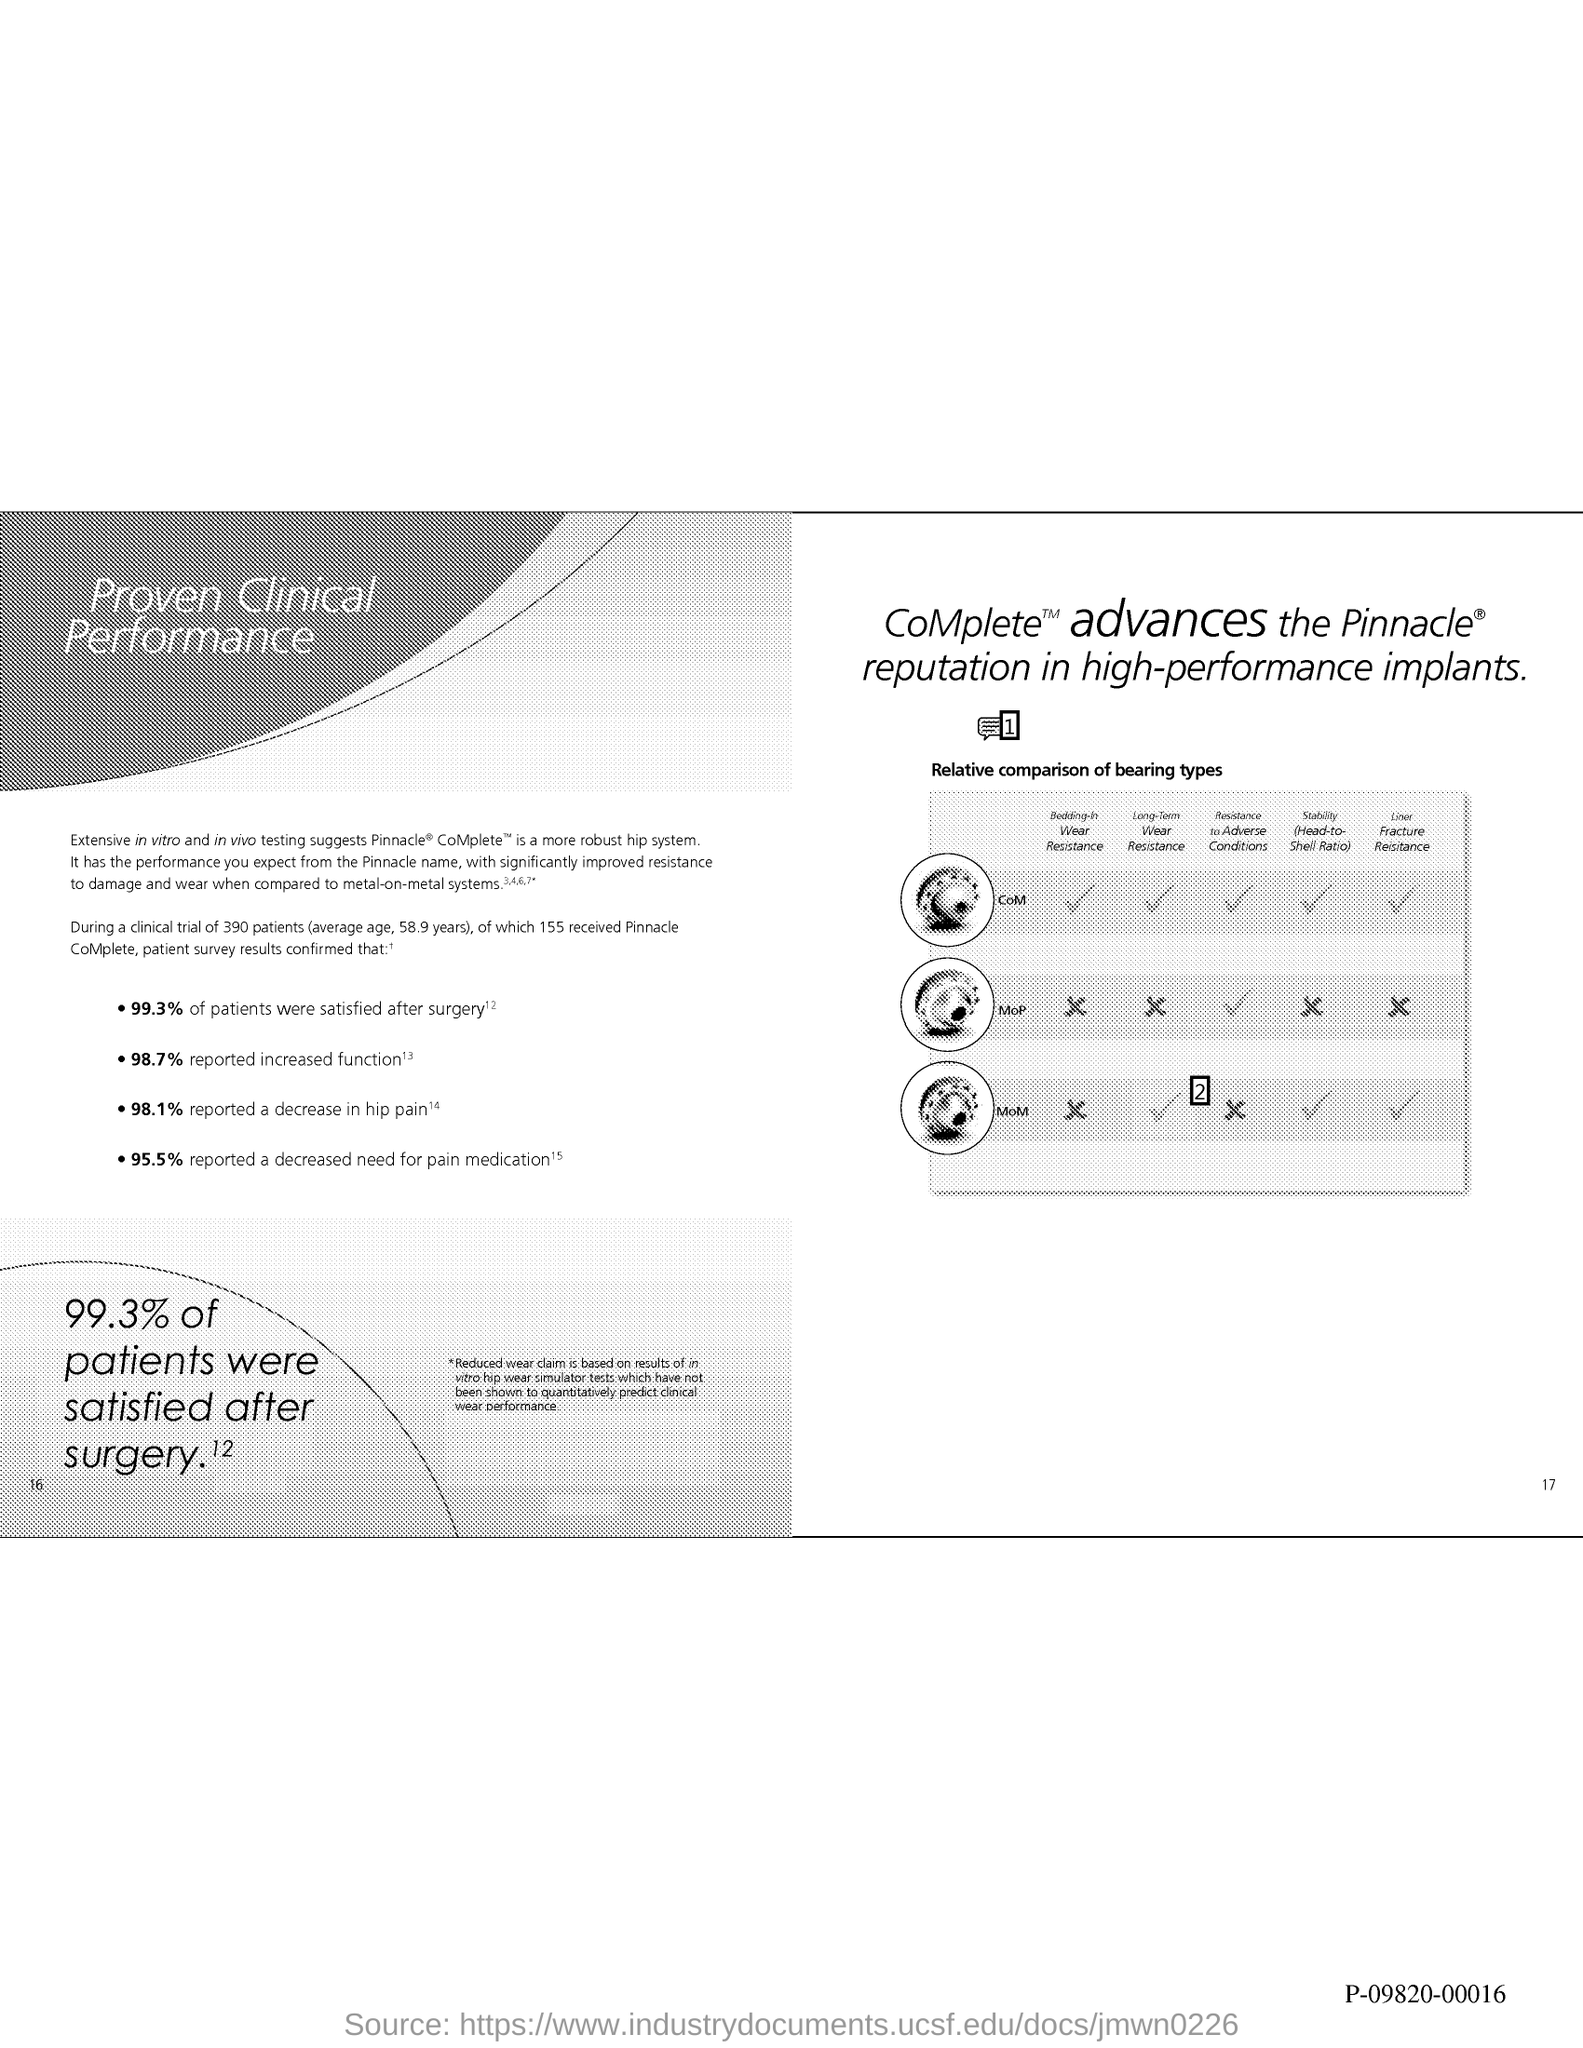Mention a couple of crucial points in this snapshot. The number at the bottom right of the page is 17. According to the reported decrease in hip pain, 98.1% of individuals experienced a reduction in their hip pain. The reported increase in function is 98.7%. Nine hundred ninety-three patients reported being satisfied after surgery, resulting in a satisfaction rate of 99.3%. According to the reported data, 95.5% of participants reported a decreased need for pain medication. 